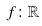Convert formula to latex. <formula><loc_0><loc_0><loc_500><loc_500>f \colon \mathbb { R }</formula> 